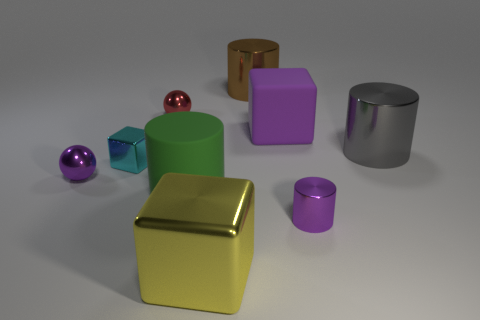What is the large cylinder that is behind the rubber thing on the right side of the metal cube in front of the small cyan shiny thing made of?
Offer a terse response. Metal. What is the color of the small metallic block?
Provide a short and direct response. Cyan. How many small objects are either yellow shiny things or shiny cylinders?
Give a very brief answer. 1. There is a small sphere that is the same color as the tiny metal cylinder; what is it made of?
Provide a succinct answer. Metal. Is the small purple thing that is to the left of the big green matte cylinder made of the same material as the big cube that is behind the yellow cube?
Offer a very short reply. No. Are any big green cylinders visible?
Your response must be concise. Yes. Are there more tiny cubes that are behind the red metallic thing than big gray metallic cylinders in front of the rubber cylinder?
Make the answer very short. No. There is a big gray thing that is the same shape as the green thing; what is its material?
Ensure brevity in your answer.  Metal. Is there anything else that has the same size as the yellow block?
Give a very brief answer. Yes. There is a big block right of the brown cylinder; does it have the same color as the big matte thing that is to the left of the large yellow thing?
Provide a succinct answer. No. 